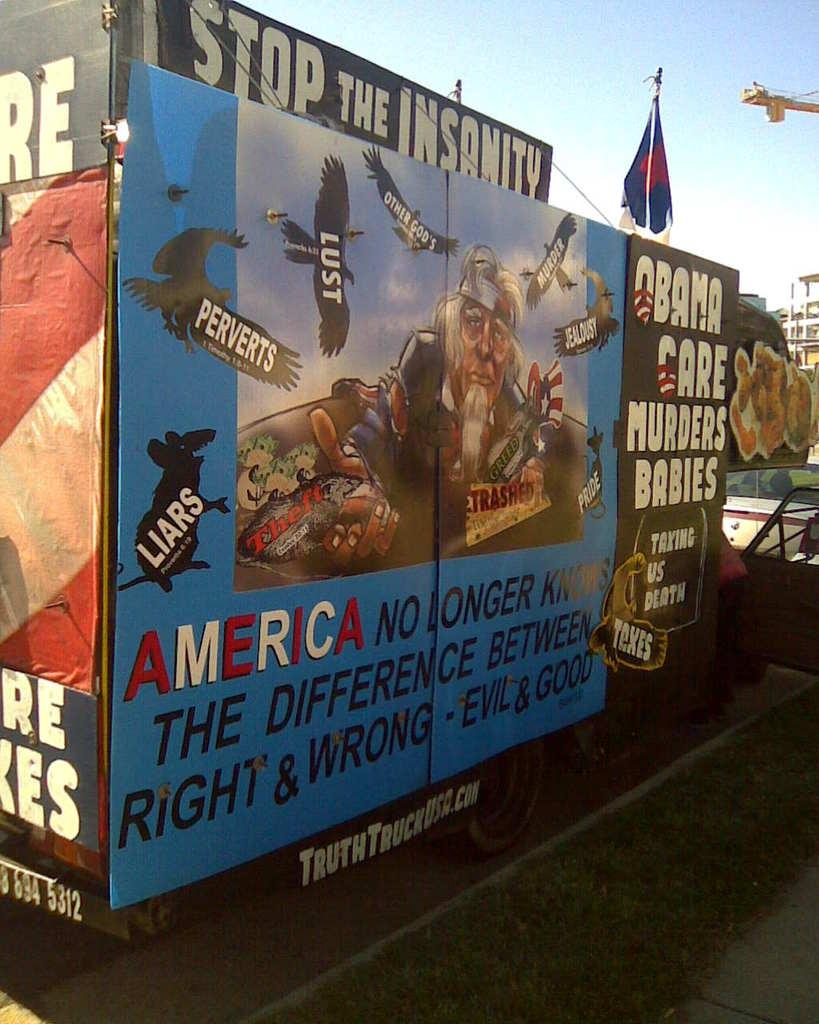<image>
Summarize the visual content of the image. Political signs cover a sides of a structure, asking that the insanity be stopped. 